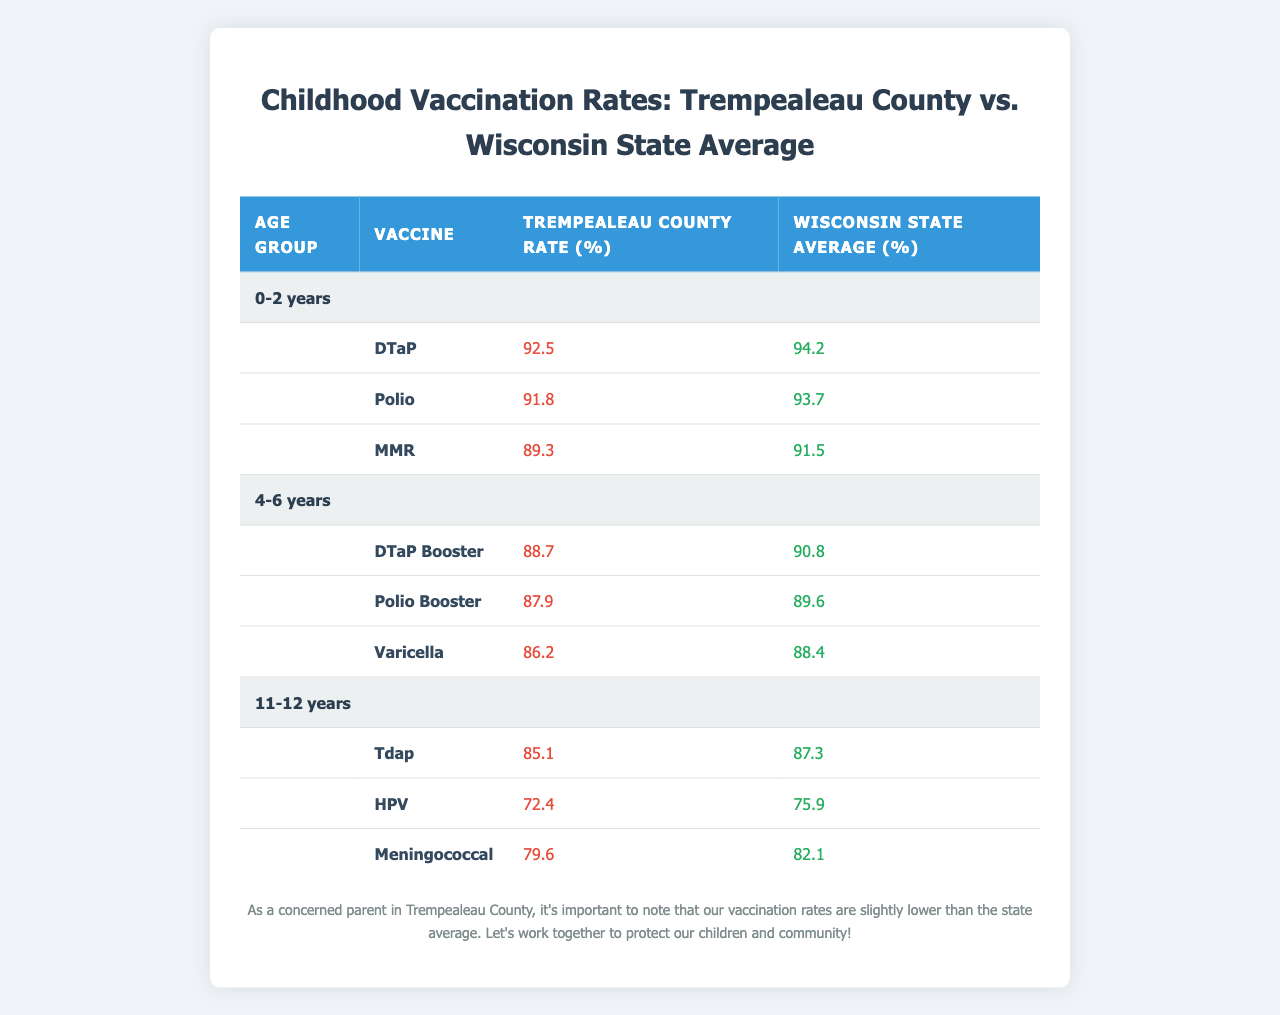What is the vaccination rate for DTaP in Trempealeau County for children aged 0-2 years? The table shows that the Trempealeau County rate for the DTaP vaccine in the 0-2 years age group is 92.5%.
Answer: 92.5% How much lower is the Polio vaccination rate in Trempealeau County compared to the Wisconsin state average for children aged 0-2 years? The Trempealeau County rate for Polio is 91.8%, while the state average is 93.7%. The difference is 93.7 - 91.8 = 1.9%.
Answer: 1.9% Is the Varicella vaccination rate in Trempealeau County higher than the state average? The Varicella rate in Trempealeau County is 86.2%, while the state average is 88.4%. Since 86.2% is less than 88.4%, the statement is false.
Answer: No What is the overall difference in vaccination rates for all vaccines listed for the age group 4-6 years between Trempealeau County and the state average? The differences are: DTaP Booster (90.8 - 88.7 = 2.1), Polio Booster (89.6 - 87.9 = 1.7), and Varicella (88.4 - 86.2 = 2.2). Sum the differences: 2.1 + 1.7 + 2.2 = 6.0%.
Answer: 6.0% What is the average vaccination rate for all vaccines in the 11-12 years age group in Trempealeau County? The vaccination rates for the 11-12 years age group are Tdap (85.1%), HPV (72.4%), and Meningococcal (79.6%). To find the average, sum these rates: 85.1 + 72.4 + 79.6 = 237.1, then divide by 3: 237.1 / 3 = 79.033.
Answer: 79.0% Which vaccine had the largest percentage gap between Trempealeau County rate and Wisconsin state average across all age groups? Looking at all vaccines, the largest gap is for HPV in the 11-12 years group: 75.9 - 72.4 = 3.5%. This is larger than any other gaps listed.
Answer: HPV For children aged 0-2 years, which vaccine has the lowest vaccination rate in Trempealeau County? The rates for the 0-2 years age group are: DTaP (92.5%), Polio (91.8%), and MMR (89.3%). The lowest rate is for MMR at 89.3%.
Answer: MMR How does the average vaccination rate in Trempealeau County for the 4-6 years group compare to the Wisconsin state average for the same group? The average in Trempealeau County is (88.7 + 87.9 + 86.2) / 3 = 87.6%, while the average state rate is (90.8 + 89.6 + 88.4) / 3 = 89.6%. The difference is 89.6 - 87.6 = 2.0%.
Answer: 2.0% lower What percentage of children aged 11-12 years in Trempealeau County received the Meningococcal vaccine? The table states that the vaccination rate for the Meningococcal vaccine for this age group in Trempealeau County is 79.6%.
Answer: 79.6% 